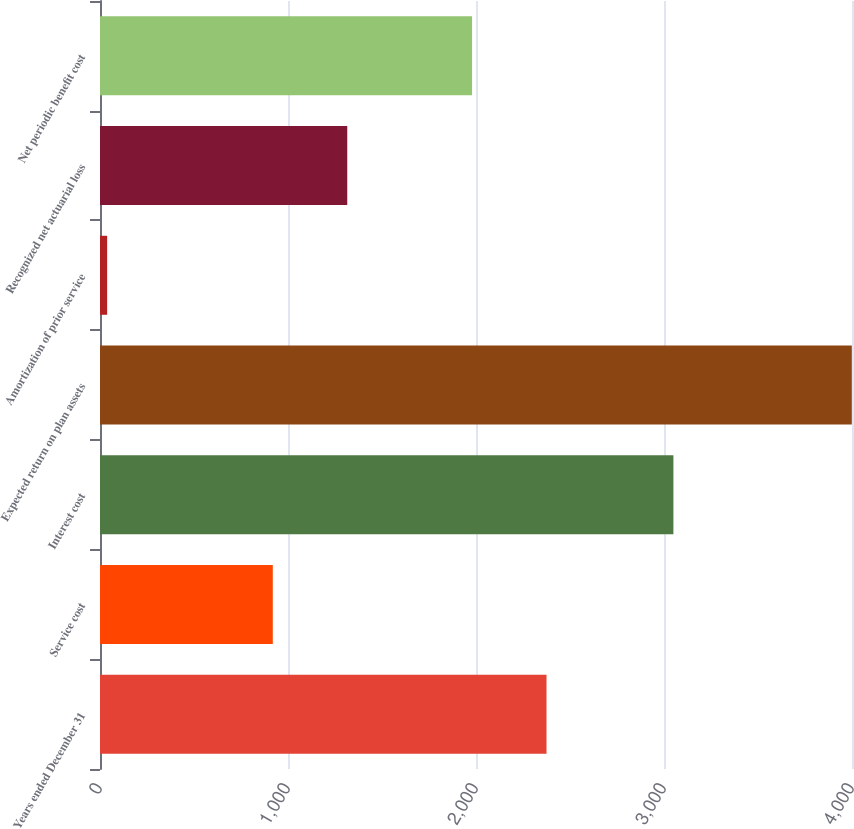Convert chart. <chart><loc_0><loc_0><loc_500><loc_500><bar_chart><fcel>Years ended December 31<fcel>Service cost<fcel>Interest cost<fcel>Expected return on plan assets<fcel>Amortization of prior service<fcel>Recognized net actuarial loss<fcel>Net periodic benefit cost<nl><fcel>2375.1<fcel>919.1<fcel>3050<fcel>3999<fcel>38<fcel>1315.2<fcel>1979<nl></chart> 